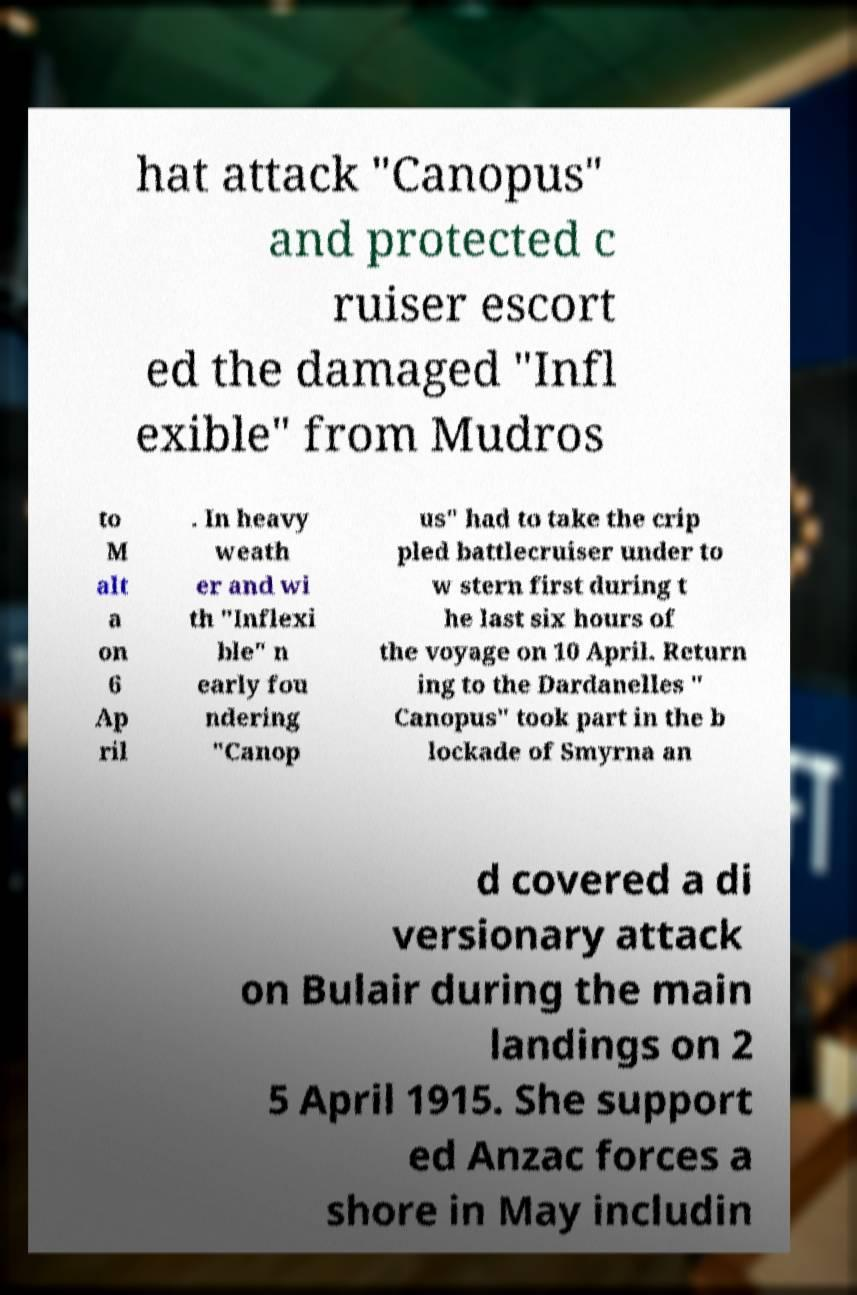Please identify and transcribe the text found in this image. hat attack "Canopus" and protected c ruiser escort ed the damaged "Infl exible" from Mudros to M alt a on 6 Ap ril . In heavy weath er and wi th "Inflexi ble" n early fou ndering "Canop us" had to take the crip pled battlecruiser under to w stern first during t he last six hours of the voyage on 10 April. Return ing to the Dardanelles " Canopus" took part in the b lockade of Smyrna an d covered a di versionary attack on Bulair during the main landings on 2 5 April 1915. She support ed Anzac forces a shore in May includin 